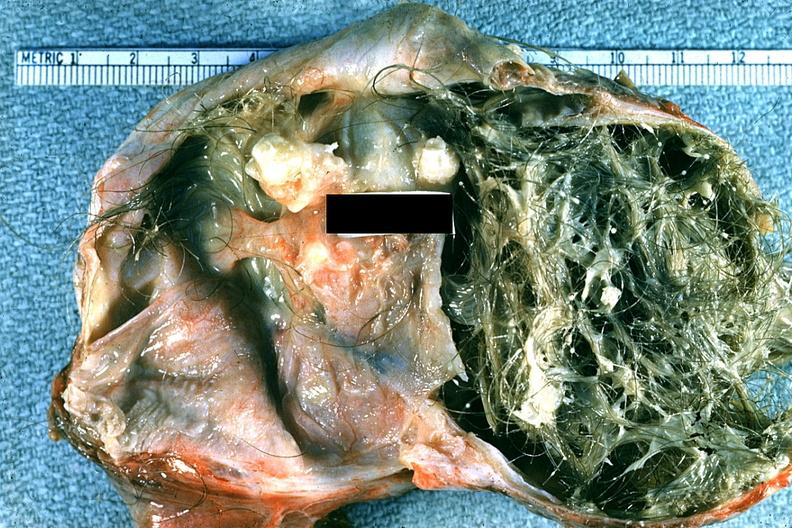where does this belong to?
Answer the question using a single word or phrase. Female reproductive system 